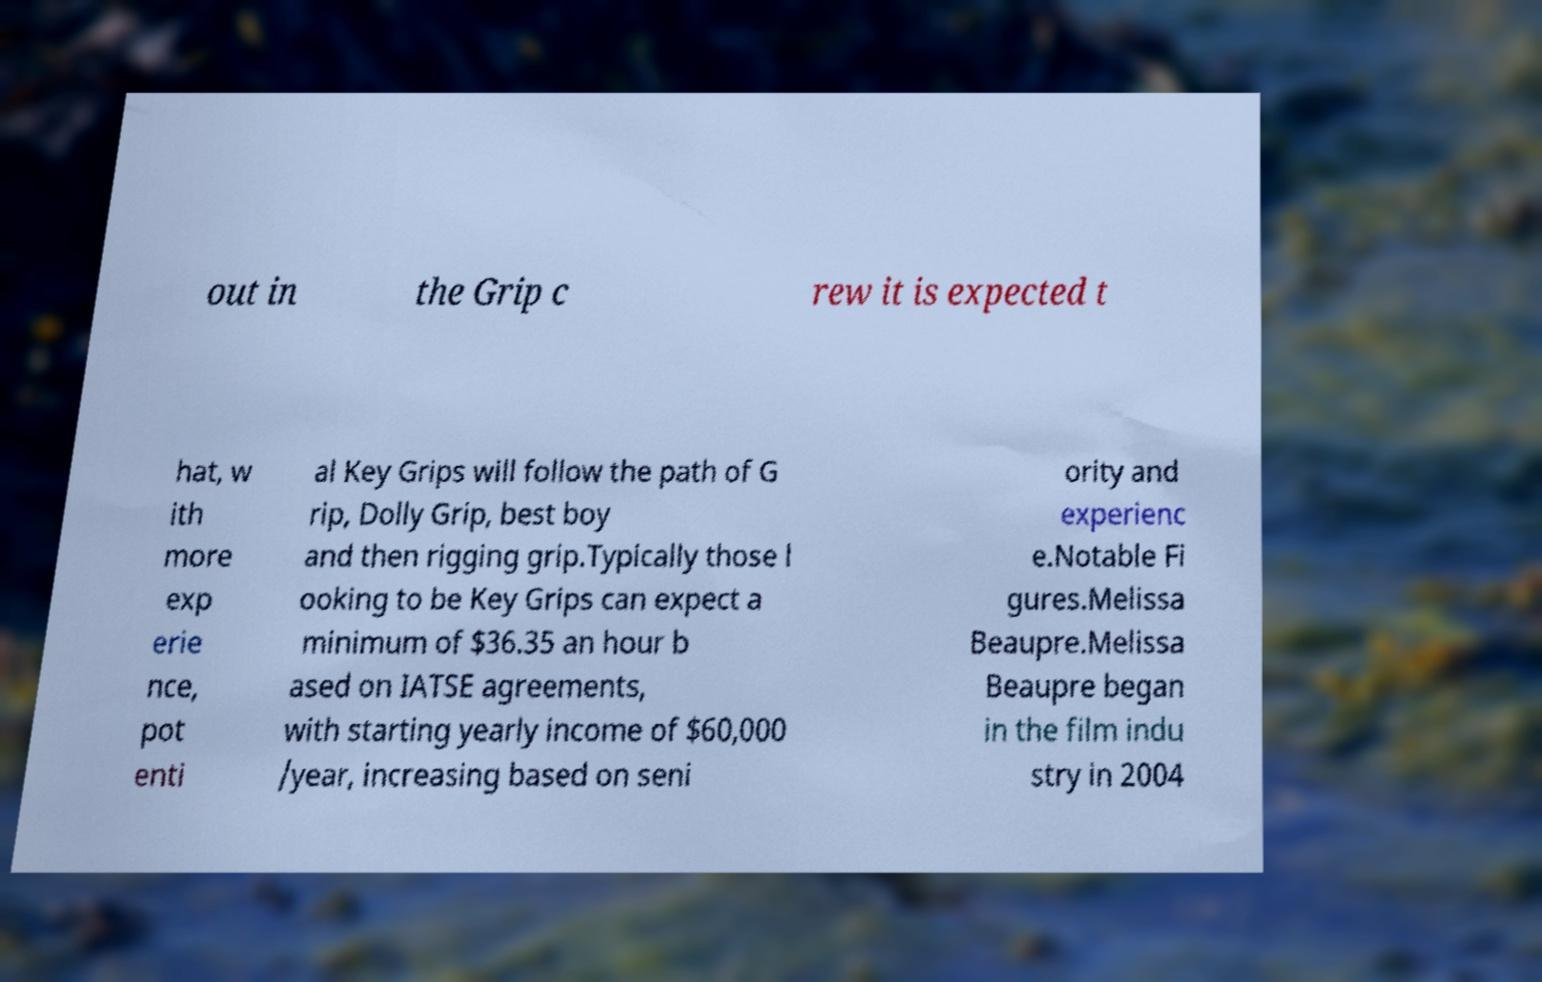Please identify and transcribe the text found in this image. out in the Grip c rew it is expected t hat, w ith more exp erie nce, pot enti al Key Grips will follow the path of G rip, Dolly Grip, best boy and then rigging grip.Typically those l ooking to be Key Grips can expect a minimum of $36.35 an hour b ased on IATSE agreements, with starting yearly income of $60,000 /year, increasing based on seni ority and experienc e.Notable Fi gures.Melissa Beaupre.Melissa Beaupre began in the film indu stry in 2004 